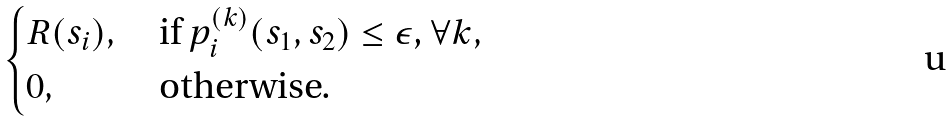<formula> <loc_0><loc_0><loc_500><loc_500>\begin{cases} R ( s _ { i } ) , & \text { if $p_{i}^{(k)}(s_{1},s_{2}) \leq \epsilon$, $\forall k$} , \\ 0 , & \text { otherwise.} \end{cases}</formula> 